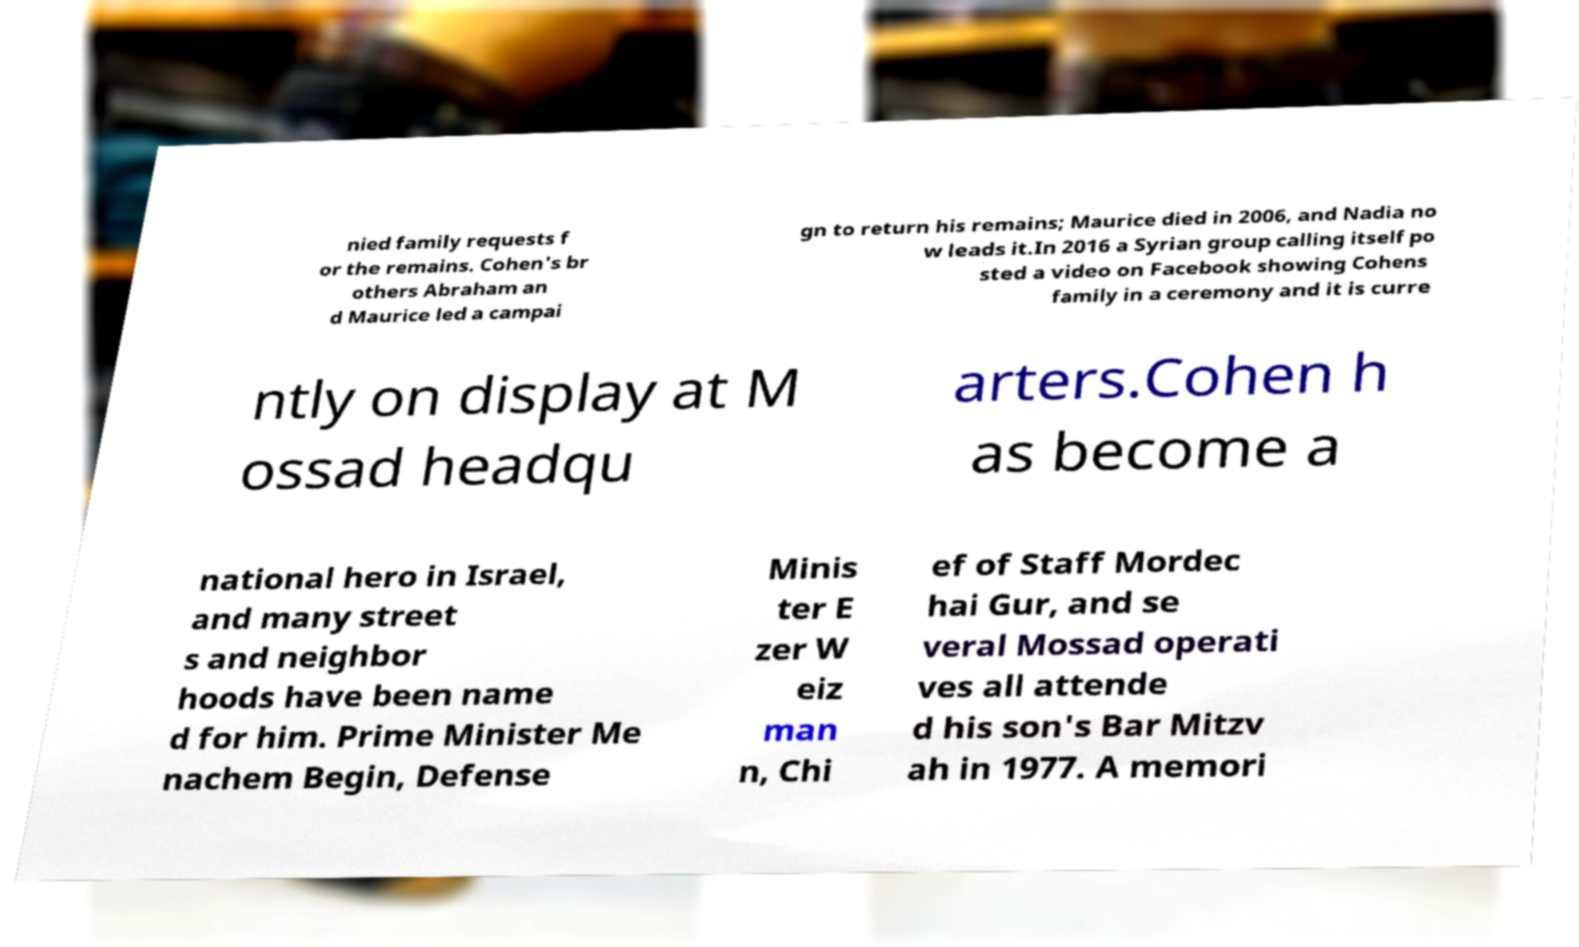Please identify and transcribe the text found in this image. nied family requests f or the remains. Cohen's br others Abraham an d Maurice led a campai gn to return his remains; Maurice died in 2006, and Nadia no w leads it.In 2016 a Syrian group calling itself po sted a video on Facebook showing Cohens family in a ceremony and it is curre ntly on display at M ossad headqu arters.Cohen h as become a national hero in Israel, and many street s and neighbor hoods have been name d for him. Prime Minister Me nachem Begin, Defense Minis ter E zer W eiz man n, Chi ef of Staff Mordec hai Gur, and se veral Mossad operati ves all attende d his son's Bar Mitzv ah in 1977. A memori 